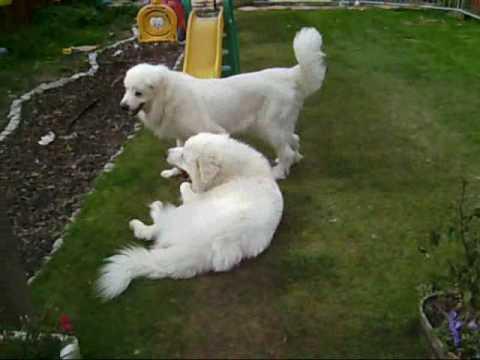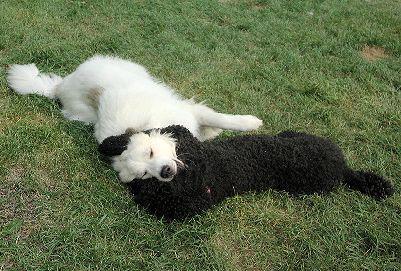The first image is the image on the left, the second image is the image on the right. Analyze the images presented: Is the assertion "Two dogs are standing in the grass in one of the images." valid? Answer yes or no. No. The first image is the image on the left, the second image is the image on the right. Given the left and right images, does the statement "An image shows a standing dog with something furry in its mouth." hold true? Answer yes or no. No. 